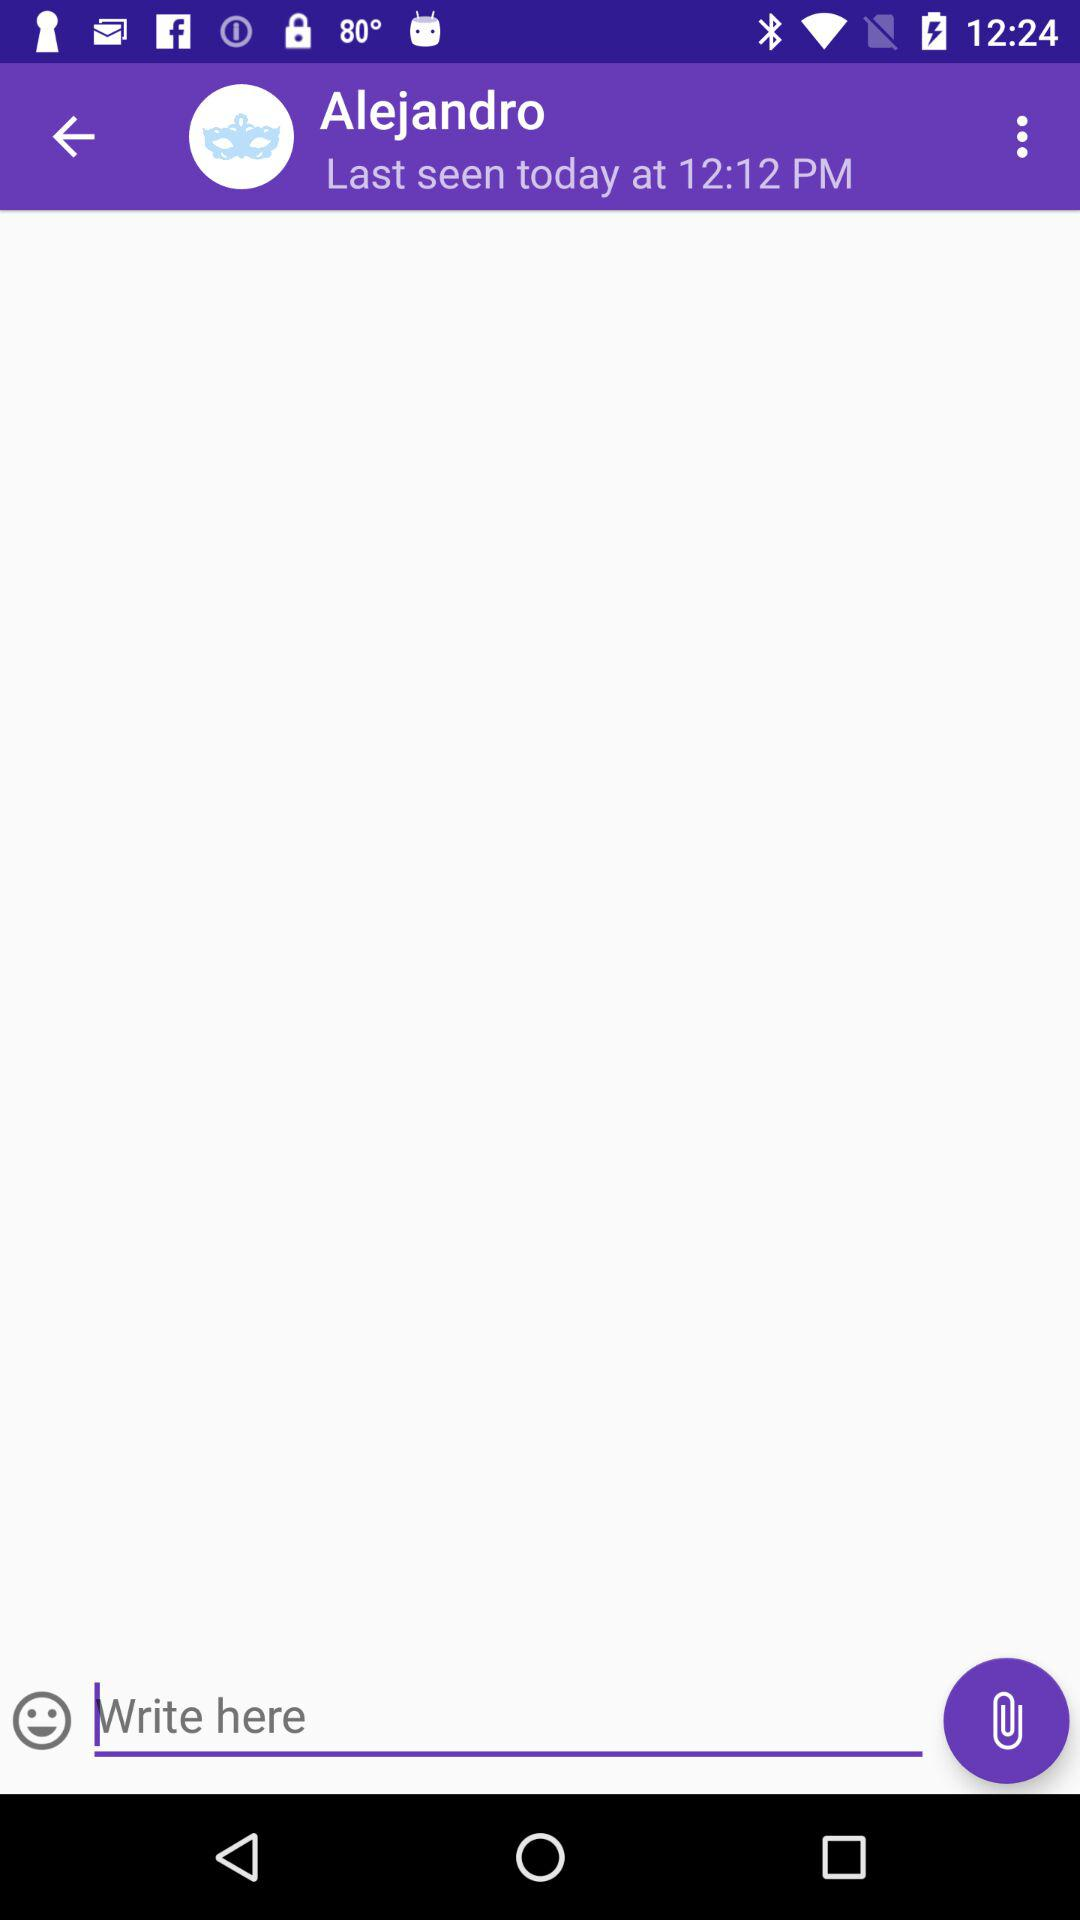When was Alejandro last seen online on chat? Alejandro was last seen online today at 12:12 PM. 